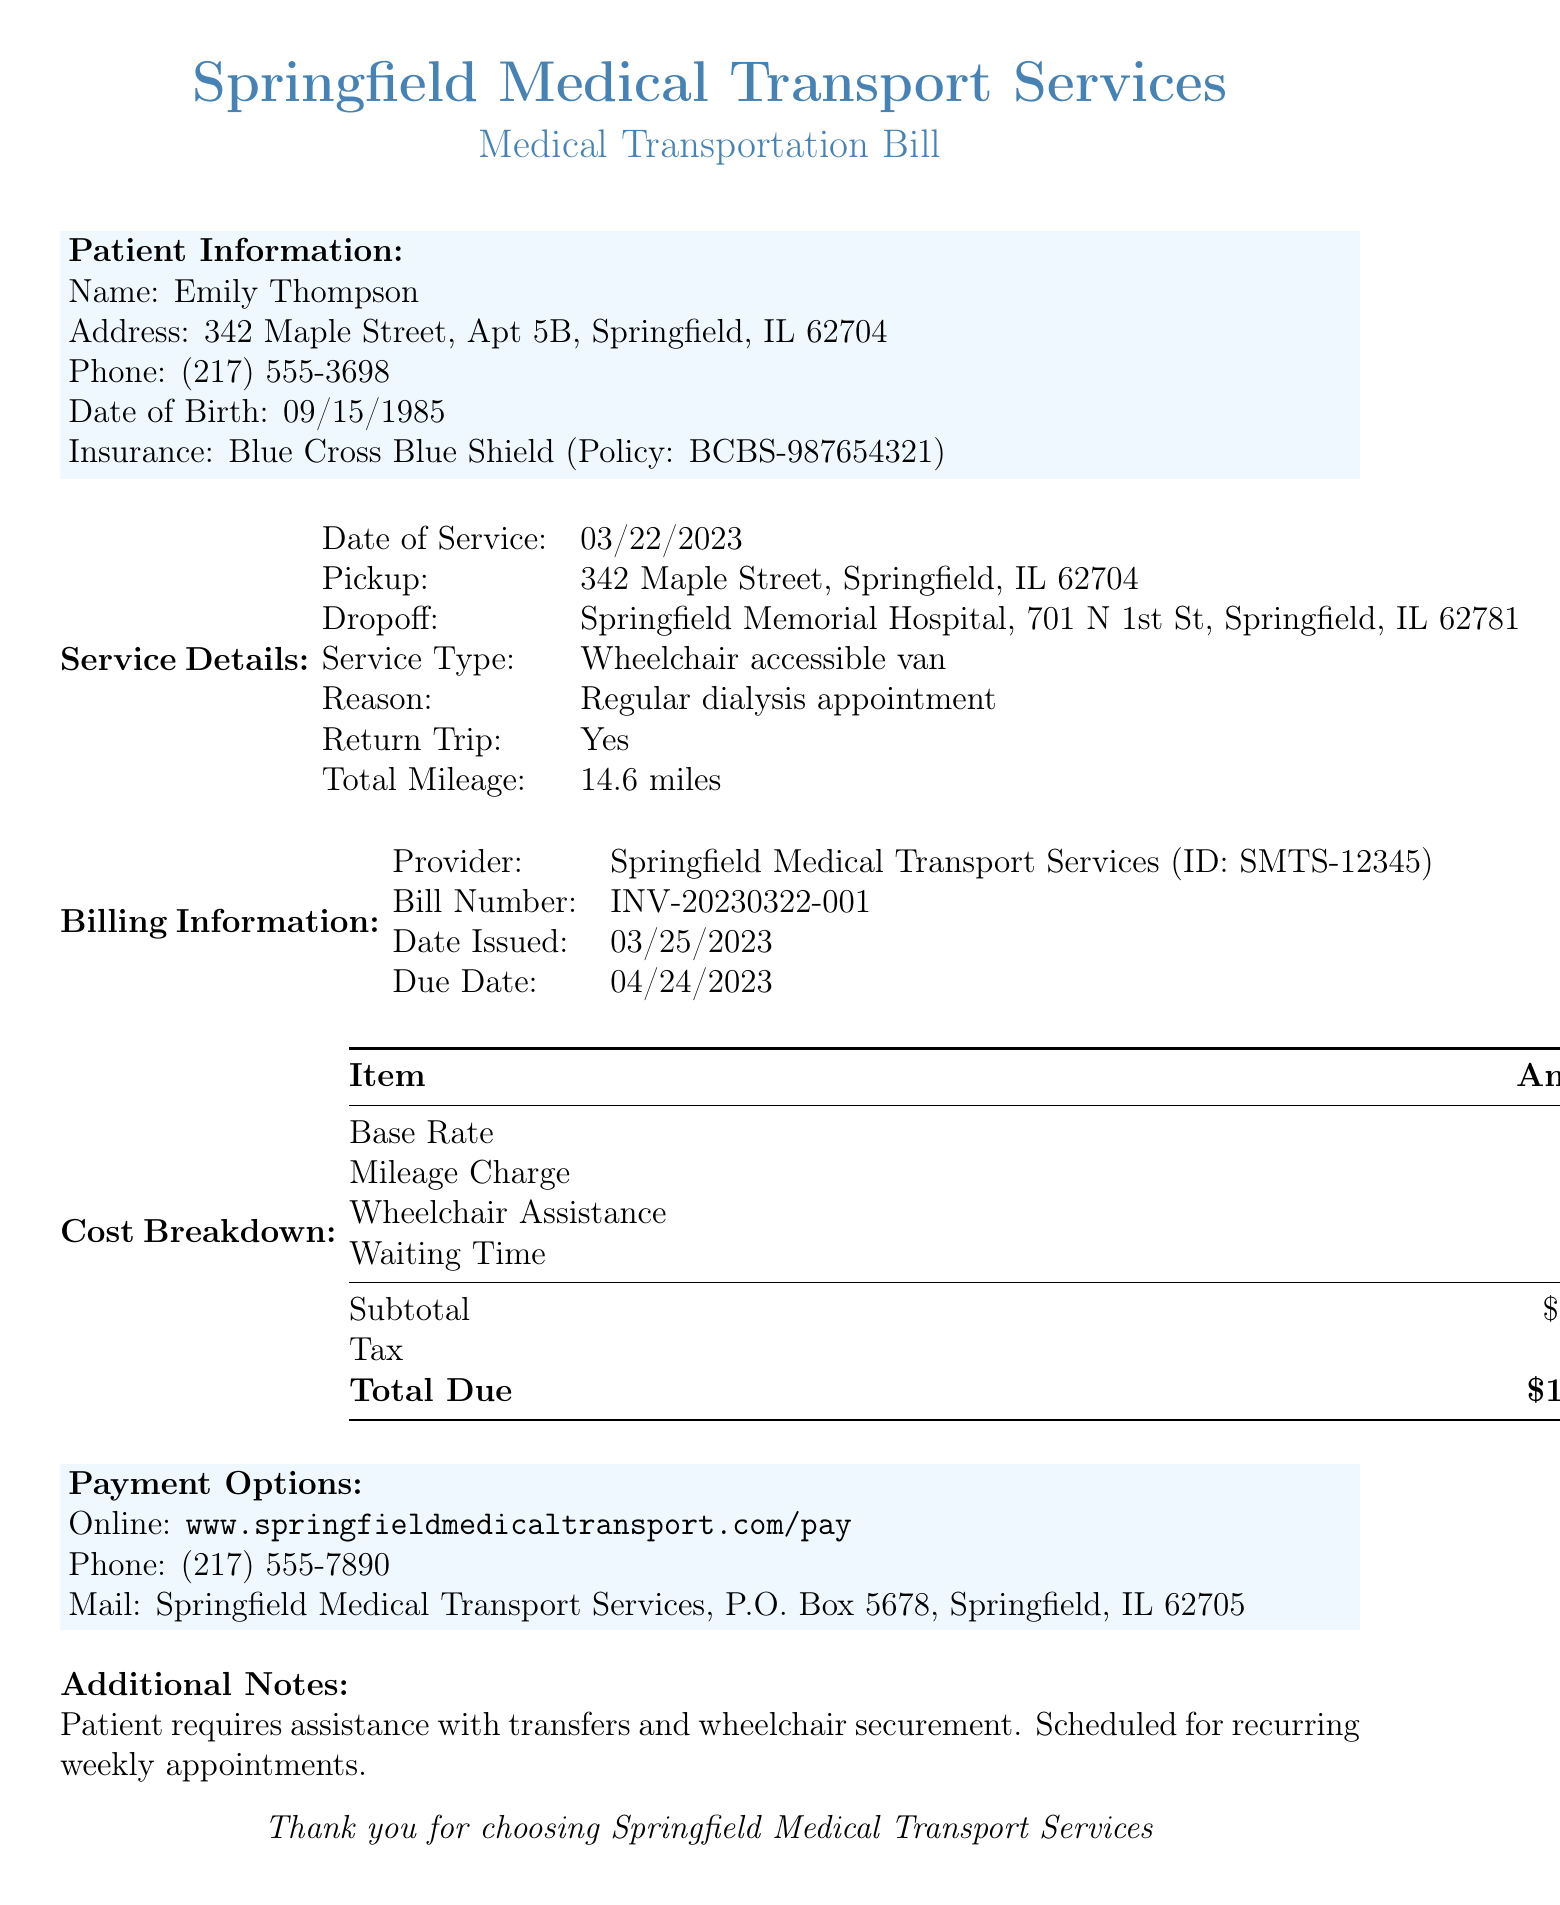What is the patient's name? The document specifies the patient's name at the top under Patient Information.
Answer: Emily Thompson What is the pickup address? The pickup address is listed in the Service Details section of the document.
Answer: 342 Maple Street, Springfield, IL 62704 What type of service was provided? The type of service is detailed in the Service Details section.
Answer: Wheelchair accessible van What is the total due amount? The total due is found in the Cost Breakdown section, specifically under Total Due.
Answer: $182.49 What was the date of service? The date of service is indicated in the Service Details section.
Answer: 03/22/2023 How much was the mileage charge? The mileage charge is specified in the Cost Breakdown section.
Answer: $43.80 How many miles were traveled in total? The total mileage is provided in the Service Details section.
Answer: 14.6 miles When is the due date for payment? The due date is listed in the Billing Information section of the document.
Answer: 04/24/2023 What is the provider's ID? The provider ID is mentioned in the Billing Information section.
Answer: SMTS-12345 